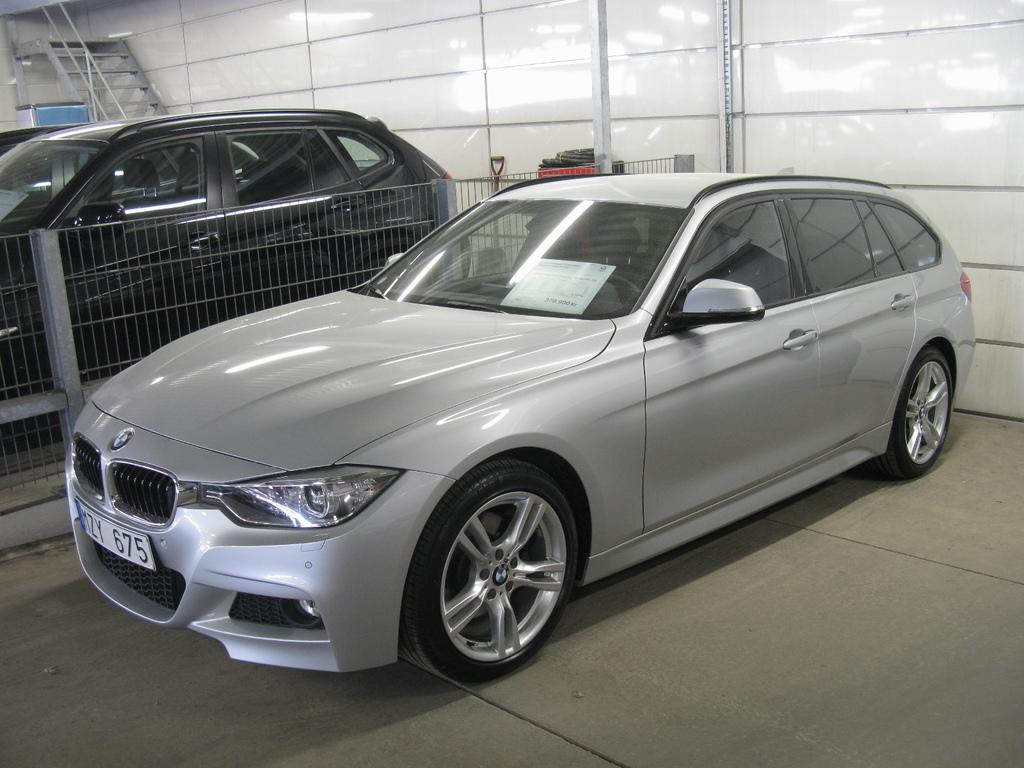What is the main subject in the front of the image? There is a car in the front of the image. What is located in the center of the image? There is a fence in the center of the image. What type of car is behind the fence? There is a black car behind the fence. Can you describe any architectural features in the image? Yes, there is a staircase and a wall in the image. What authority figure can be seen in the image? There is no authority figure present in the image. What role does the father play in the image? There is no father present in the image. 